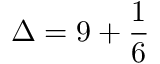<formula> <loc_0><loc_0><loc_500><loc_500>\Delta = 9 + { \frac { 1 } { 6 } }</formula> 